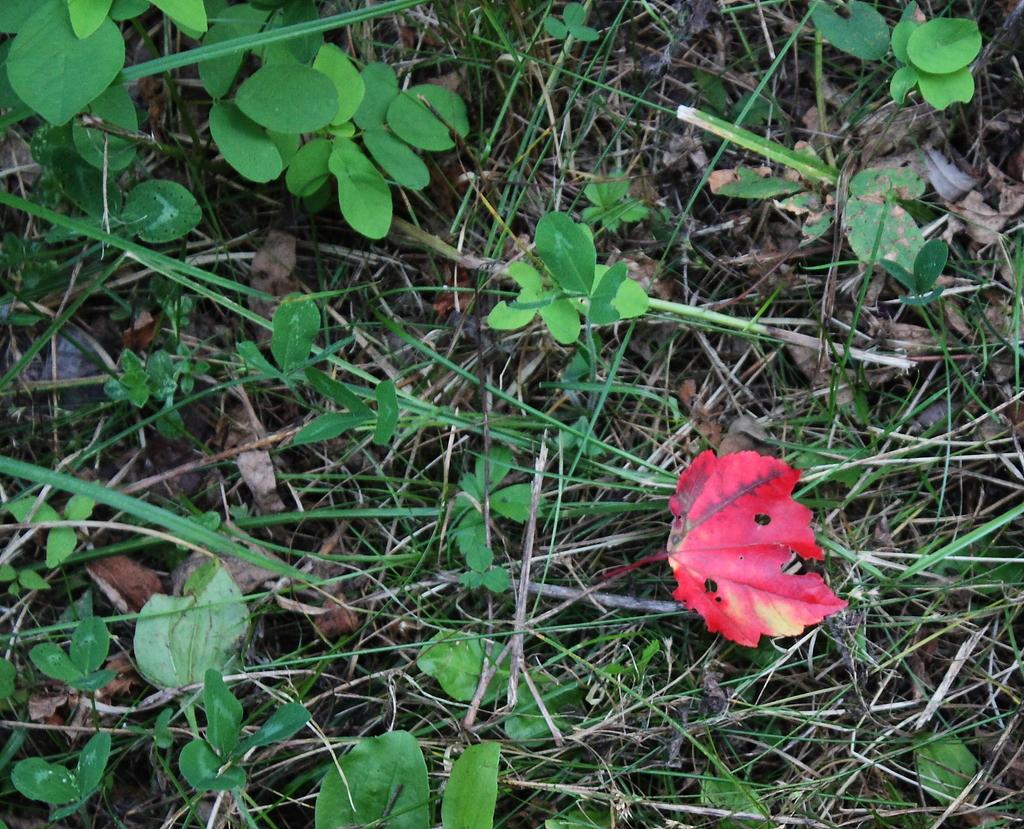What is located in the center of the image? There are plants in the center of the image. What objects can be seen alongside the plants? Thin sticks and dry leaves are present in the image. Are there any leaves with a specific color in the image? Yes, there is one red leaf in the image. What type of behavior can be observed in the pen in the image? There is no pen present in the image; it features plants, thin sticks, dry leaves, and a red leaf. 